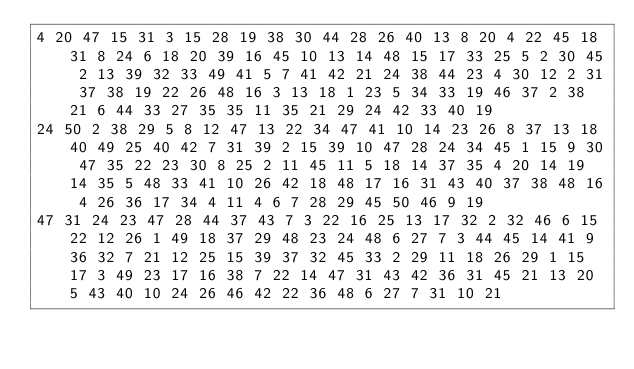Convert code to text. <code><loc_0><loc_0><loc_500><loc_500><_Matlab_>4 20 47 15 31 3 15 28 19 38 30 44 28 26 40 13 8 20 4 22 45 18 31 8 24 6 18 20 39 16 45 10 13 14 48 15 17 33 25 5 2 30 45 2 13 39 32 33 49 41 5 7 41 42 21 24 38 44 23 4 30 12 2 31 37 38 19 22 26 48 16 3 13 18 1 23 5 34 33 19 46 37 2 38 21 6 44 33 27 35 35 11 35 21 29 24 42 33 40 19
24 50 2 38 29 5 8 12 47 13 22 34 47 41 10 14 23 26 8 37 13 18 40 49 25 40 42 7 31 39 2 15 39 10 47 28 24 34 45 1 15 9 30 47 35 22 23 30 8 25 2 11 45 11 5 18 14 37 35 4 20 14 19 14 35 5 48 33 41 10 26 42 18 48 17 16 31 43 40 37 38 48 16 4 26 36 17 34 4 11 4 6 7 28 29 45 50 46 9 19
47 31 24 23 47 28 44 37 43 7 3 22 16 25 13 17 32 2 32 46 6 15 22 12 26 1 49 18 37 29 48 23 24 48 6 27 7 3 44 45 14 41 9 36 32 7 21 12 25 15 39 37 32 45 33 2 29 11 18 26 29 1 15 17 3 49 23 17 16 38 7 22 14 47 31 43 42 36 31 45 21 13 20 5 43 40 10 24 26 46 42 22 36 48 6 27 7 31 10 21</code> 